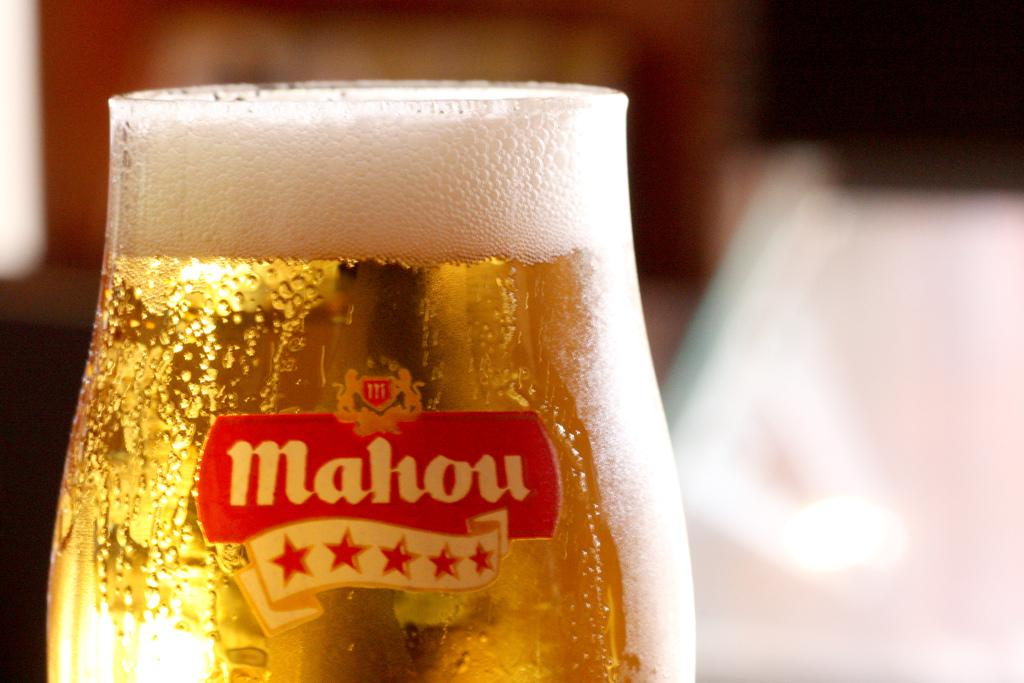Provide a one-sentence caption for the provided image. A freshly poured glass of Mahou beer filled with foam in glass in on a table. 